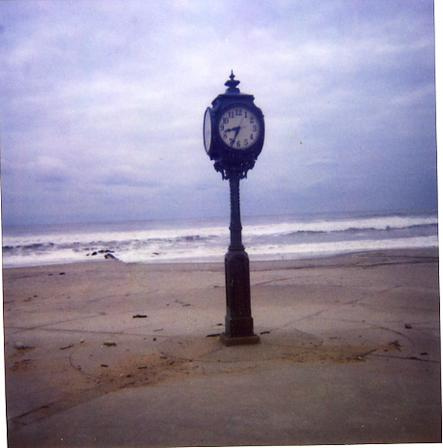Please extract the text content from this image. 12 11 10 9 8 7 6 5 4 3 2 1 